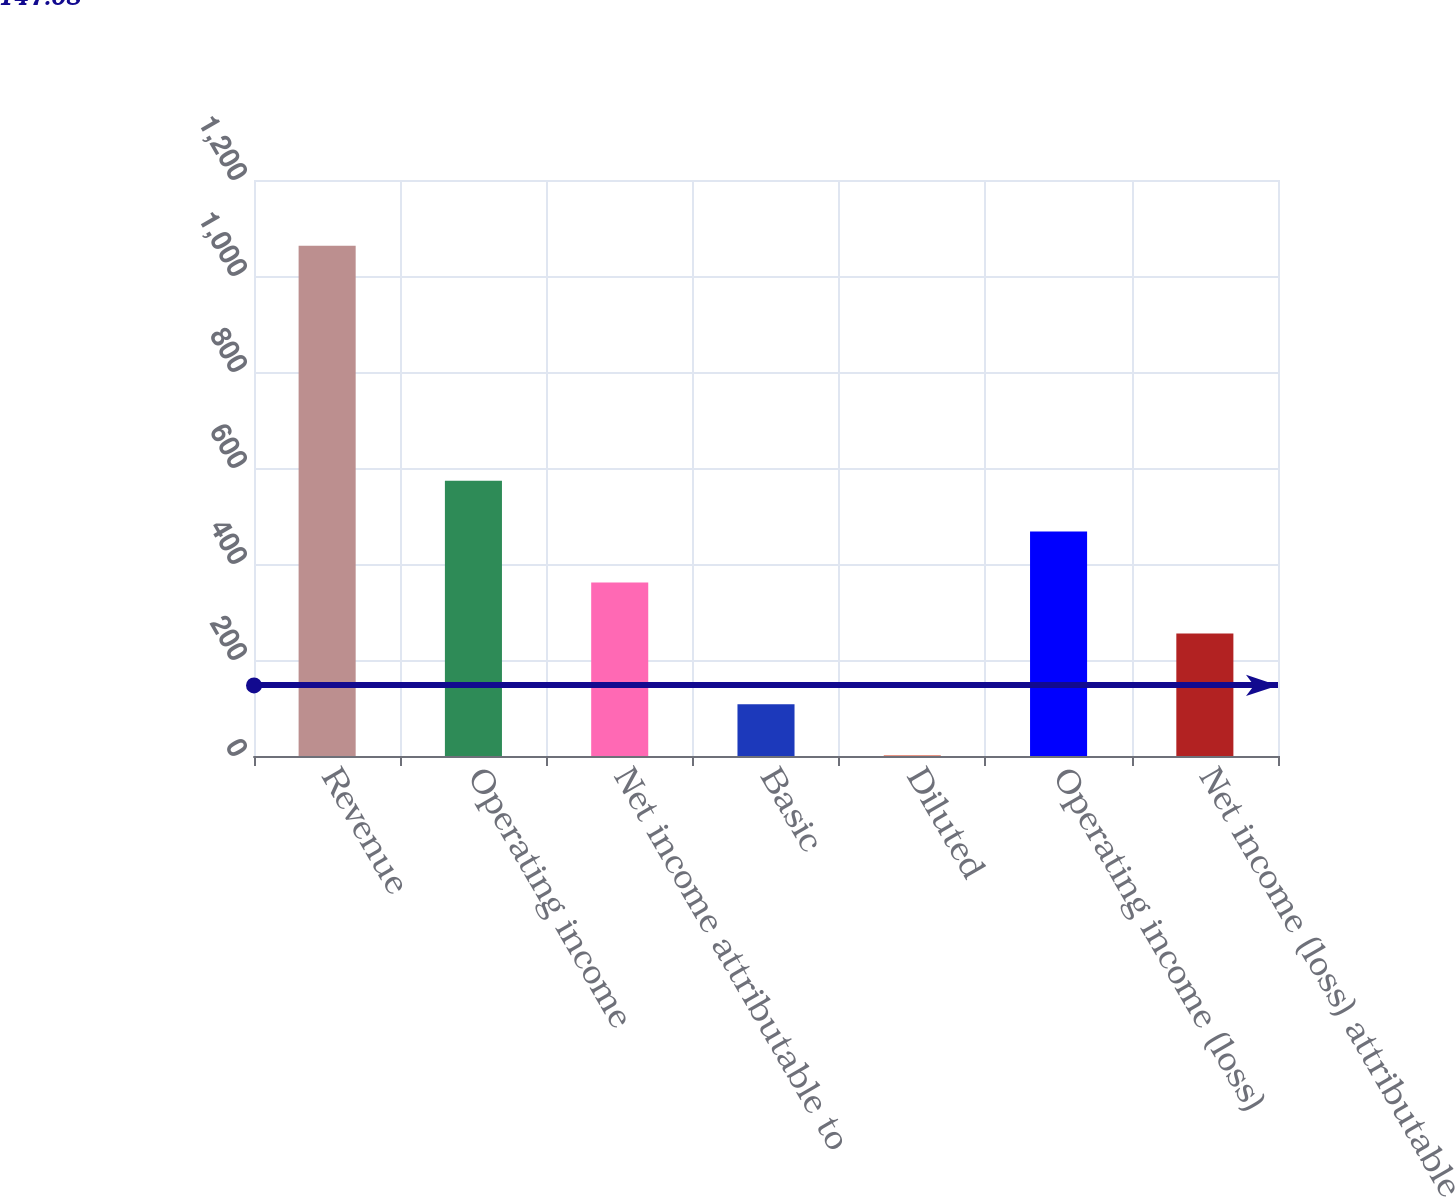Convert chart. <chart><loc_0><loc_0><loc_500><loc_500><bar_chart><fcel>Revenue<fcel>Operating income<fcel>Net income attributable to<fcel>Basic<fcel>Diluted<fcel>Operating income (loss)<fcel>Net income (loss) attributable<nl><fcel>1062.9<fcel>573.69<fcel>361.43<fcel>107.76<fcel>1.63<fcel>467.56<fcel>255.3<nl></chart> 